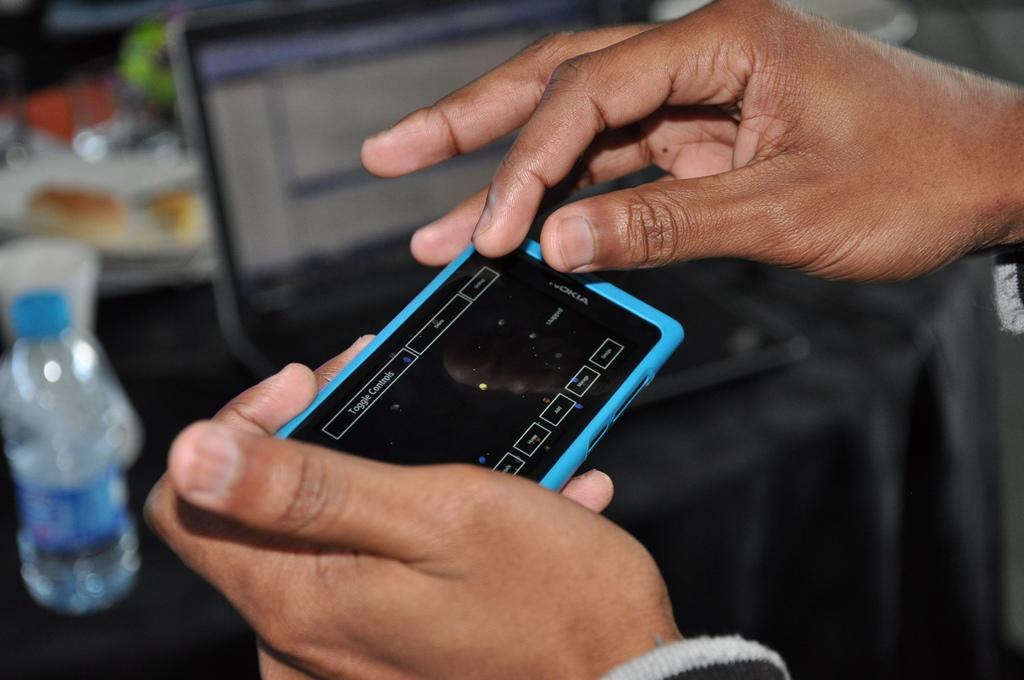<image>
Render a clear and concise summary of the photo. a Nokia cell phone with a blue cover held in someone's hands 